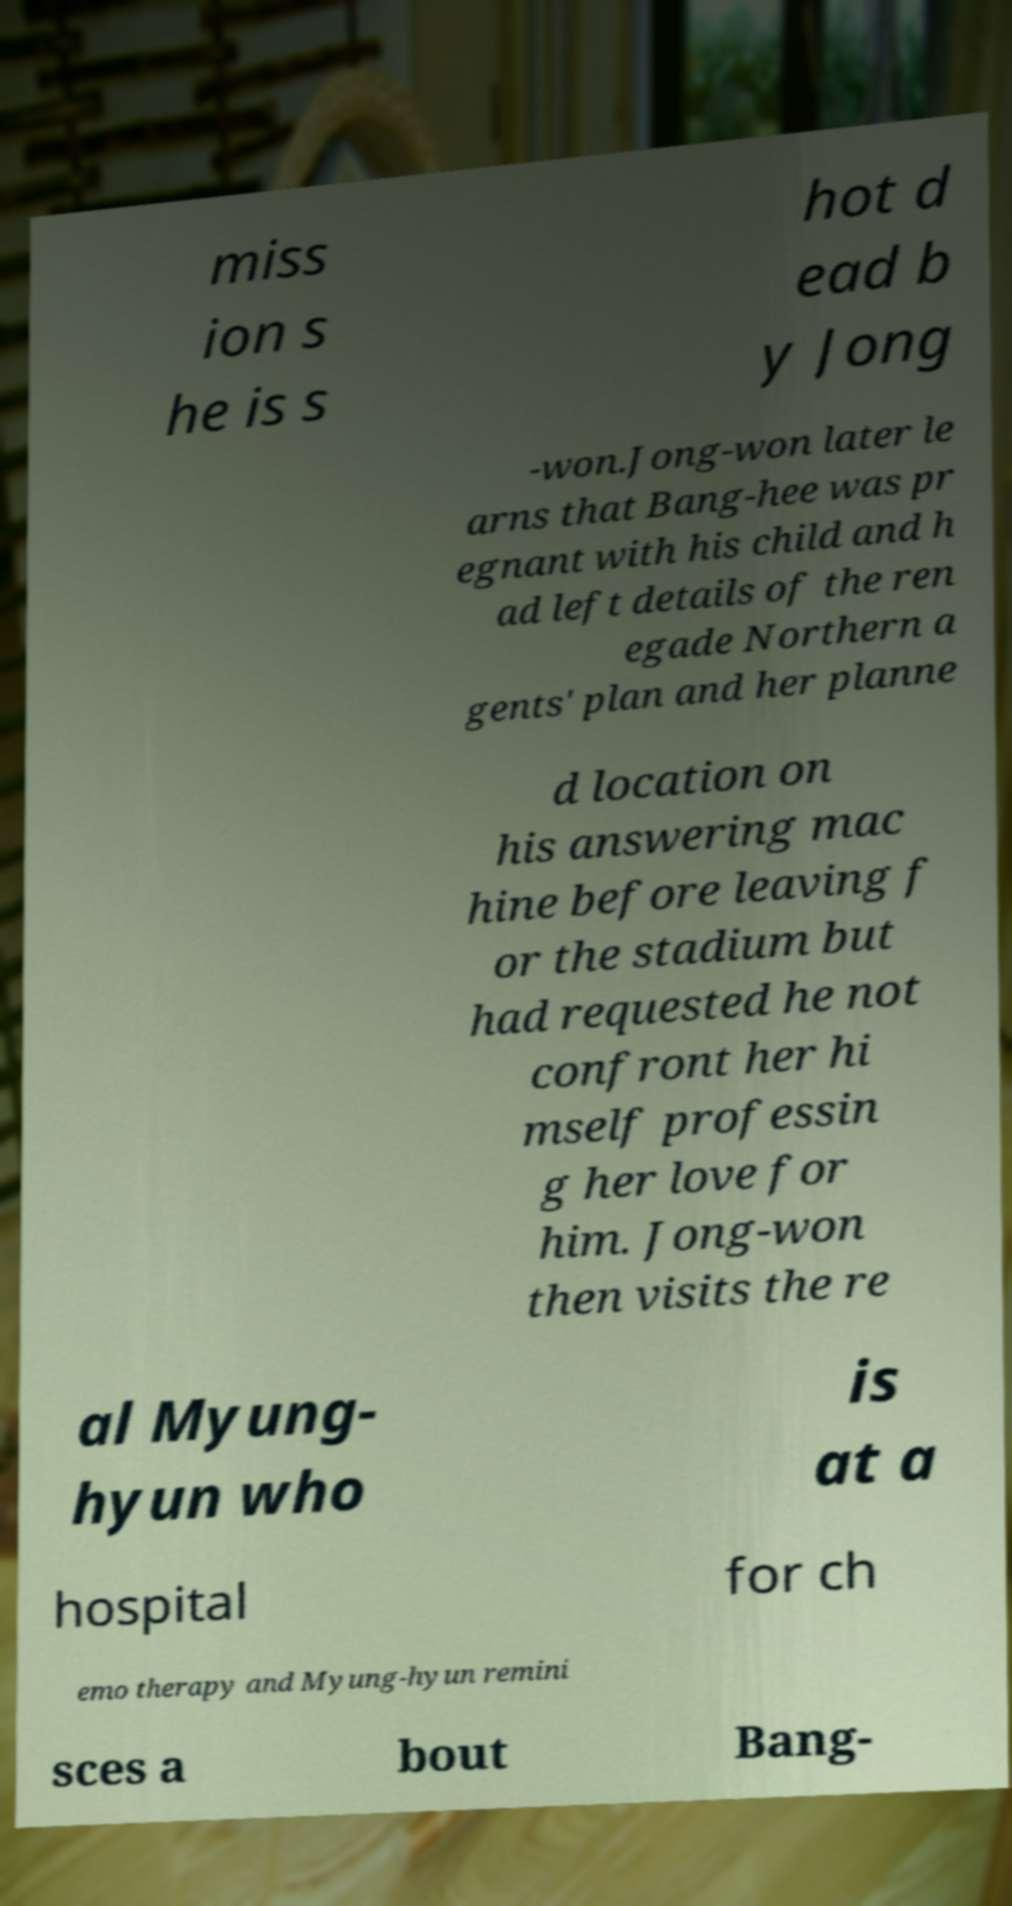Please read and relay the text visible in this image. What does it say? miss ion s he is s hot d ead b y Jong -won.Jong-won later le arns that Bang-hee was pr egnant with his child and h ad left details of the ren egade Northern a gents' plan and her planne d location on his answering mac hine before leaving f or the stadium but had requested he not confront her hi mself professin g her love for him. Jong-won then visits the re al Myung- hyun who is at a hospital for ch emo therapy and Myung-hyun remini sces a bout Bang- 